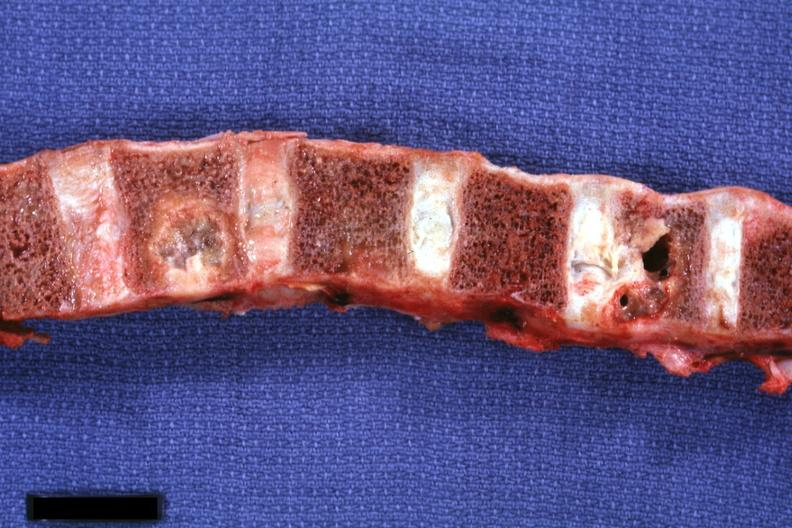what does this image show?
Answer the question using a single word or phrase. Sectioned vertebral bodies showing very nicely osteolytic metastatic lesions primary squamous cell carcinoma penis 